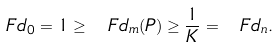<formula> <loc_0><loc_0><loc_500><loc_500>\ F d _ { 0 } = 1 \geq \ F d _ { m } ( P ) \geq \frac { 1 } { K } = \ F d _ { n } .</formula> 